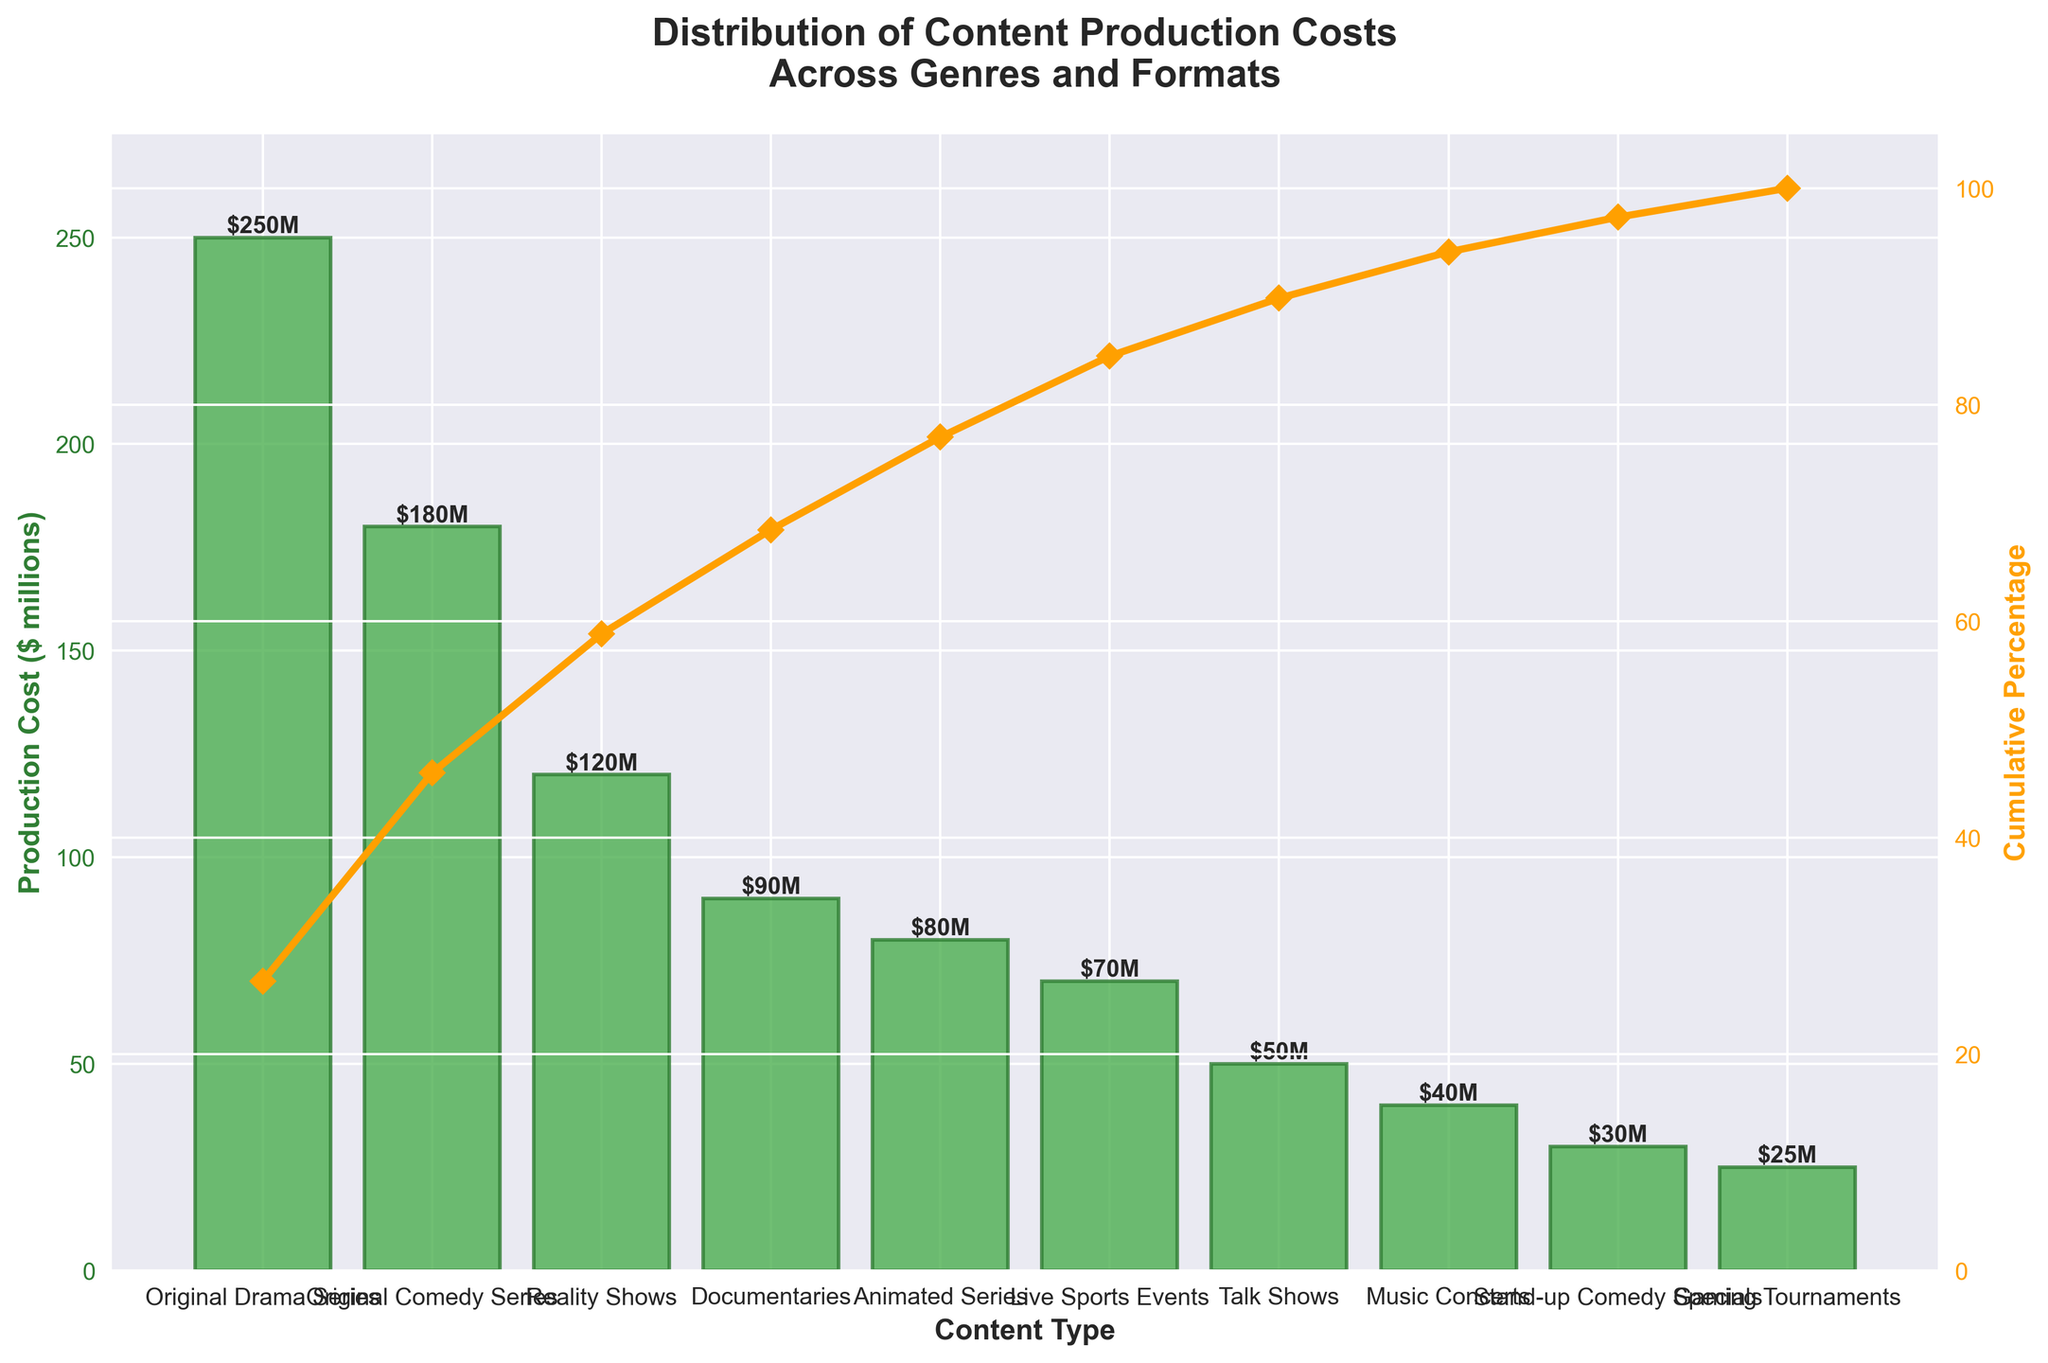What's the overall title of the figure? The title of the figure is usually displayed prominently at the top. It provides a summary of what the visual data represents. Look at the top of the figure to find the title.
Answer: Distribution of Content Production Costs Across Genres and Formats How many content types are represented in the figure? Count the number of distinct bars on the primary y-axis (left side) that correspond to different content types. Each bar represents a different content type.
Answer: 10 What content type has the highest production cost? Identify the tallest bar in the bar chart. The content type corresponding to this bar will have the highest production cost.
Answer: Original Drama Series Which content type contributes the least to production costs? Find the shortest bar in the bar chart. The content type corresponding to this bar will have the least production cost.
Answer: Gaming Tournaments What are the production costs of Original Comedy Series compared to Original Drama Series? Compare the heights of the bars for Original Comedy Series and Original Drama Series. Read the values from the top of each bar.
Answer: Original Drama Series: $250M, Original Comedy Series: $180M What is the cumulative percentage of production costs up to Reality Shows? Follow the cumulative percentage line (secondary y-axis) up to Reality Shows and read the corresponding value. This value represents the cumulative percentage of the total production costs up to that content type.
Answer: 66% What is the total production cost for the content types shown? Sum the production costs for all content types represented in the figure. Add the values from each bar to get the total production cost. (250 + 180 + 120 + 90 + 80 + 70 + 50 + 40 + 30 + 25)
Answer: $935M How do Documentaries and Animated Series compare in terms of cumulative percentage? Find the points on the cumulative percentage line corresponding to Documentaries and Animated Series. Compare the values for these two points.
Answer: Documentaries: 68%, Animated Series: 77% What percentage of the total production cost does the top three content types represent? Identify the top three content types in terms of production cost (Original Drama Series, Original Comedy Series, Reality Shows). Sum their costs and divide by the total production cost, then multiply by 100 to get the percentage. (250 + 180 + 120) / 935 * 100 = 58.61%
Answer: 58.61% What insight can you derive about the distribution of production costs across content types? Based on the Pareto chart, a significant portion of the total production cost is concentrated in a few content types. The cumulative percentage line shows how quickly the costs are accumulated with the addition of each content type.
Answer: A few content types dominate production costs 